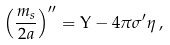Convert formula to latex. <formula><loc_0><loc_0><loc_500><loc_500>\left ( \frac { m _ { s } } { 2 a } \right ) ^ { \prime \prime } = \Upsilon - 4 \pi \sigma ^ { \prime } \eta \, ,</formula> 